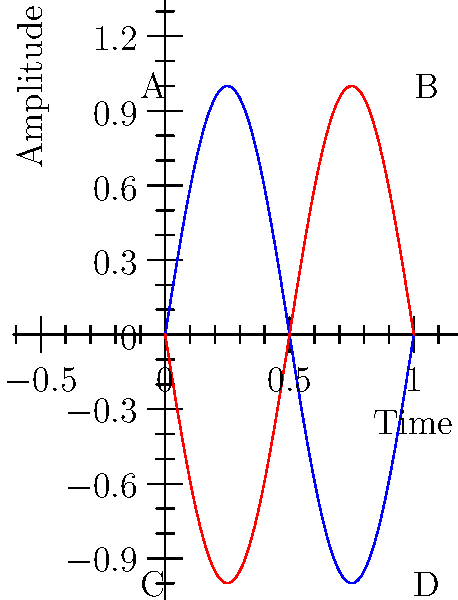In your latest electronic blues composition, you've created a waveform represented by the blue sine curve in the graph above. You're considering adding a complementary waveform, shown in red. If the blue waveform is described by the function $f(x) = \sin(2\pi x)$ and the red waveform by $g(x) = -\sin(2\pi x)$, what type of symmetry exists between these two waveforms with respect to the x-axis? Additionally, what is the area of the rectangle ABCD formed by the maximum and minimum points of these waveforms? To answer this question, let's break it down step-by-step:

1. Symmetry analysis:
   - The blue curve is $f(x) = \sin(2\pi x)$
   - The red curve is $g(x) = -\sin(2\pi x)$
   - We can see that $g(x) = -f(x)$
   - This relationship indicates that the two curves are reflections of each other across the x-axis, which is known as odd symmetry.

2. Area calculation:
   - The rectangle ABCD is formed by the maximum and minimum points of the waveforms.
   - For a sine function, the maximum amplitude is 1 and the minimum is -1.
   - The width of the rectangle is 1, which represents one full cycle of the sine wave.
   - The height of the rectangle is the distance between the maximum (1) and minimum (-1) points, which is 2.
   - Area of a rectangle = width * height
   - Area = 1 * 2 = 2 square units

Therefore, the waveforms exhibit odd symmetry with respect to the x-axis, and the area of the rectangle ABCD is 2 square units.
Answer: Odd symmetry; 2 square units 